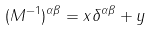<formula> <loc_0><loc_0><loc_500><loc_500>( M ^ { - 1 } ) ^ { \alpha \beta } = x \delta ^ { \alpha \beta } + y</formula> 